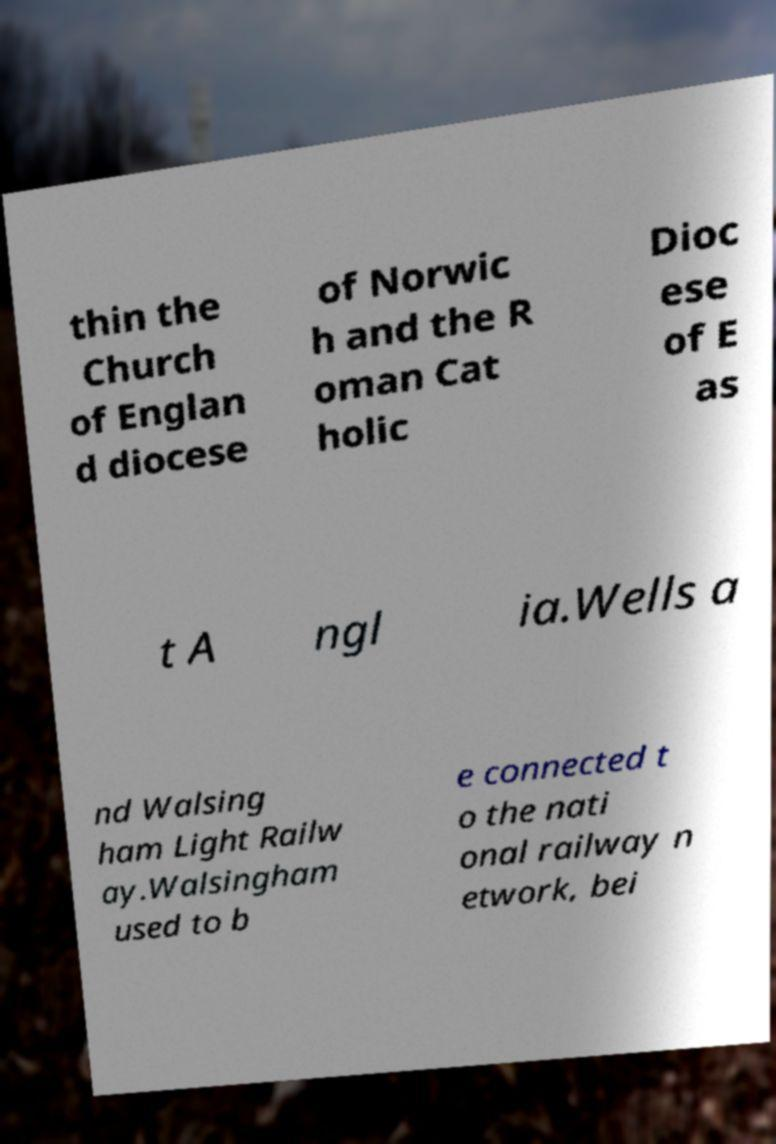What messages or text are displayed in this image? I need them in a readable, typed format. thin the Church of Englan d diocese of Norwic h and the R oman Cat holic Dioc ese of E as t A ngl ia.Wells a nd Walsing ham Light Railw ay.Walsingham used to b e connected t o the nati onal railway n etwork, bei 